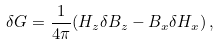Convert formula to latex. <formula><loc_0><loc_0><loc_500><loc_500>\delta G = \frac { 1 } { 4 \pi } ( H _ { z } \delta B _ { z } - B _ { x } \delta H _ { x } ) \, ,</formula> 